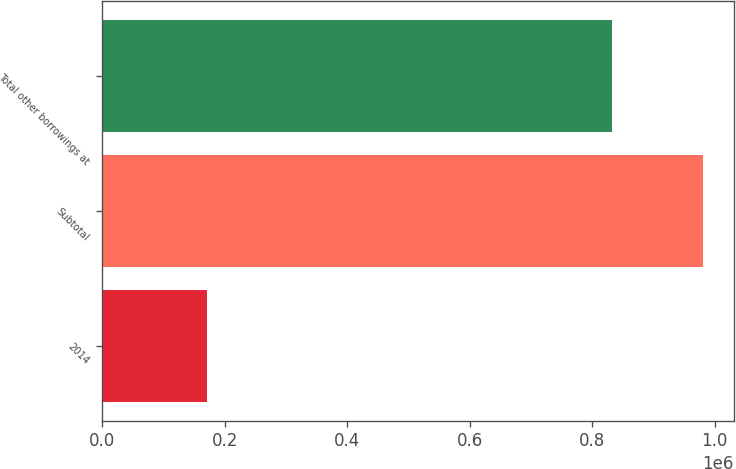Convert chart. <chart><loc_0><loc_0><loc_500><loc_500><bar_chart><fcel>2014<fcel>Subtotal<fcel>Total other borrowings at<nl><fcel>170000<fcel>981749<fcel>831749<nl></chart> 